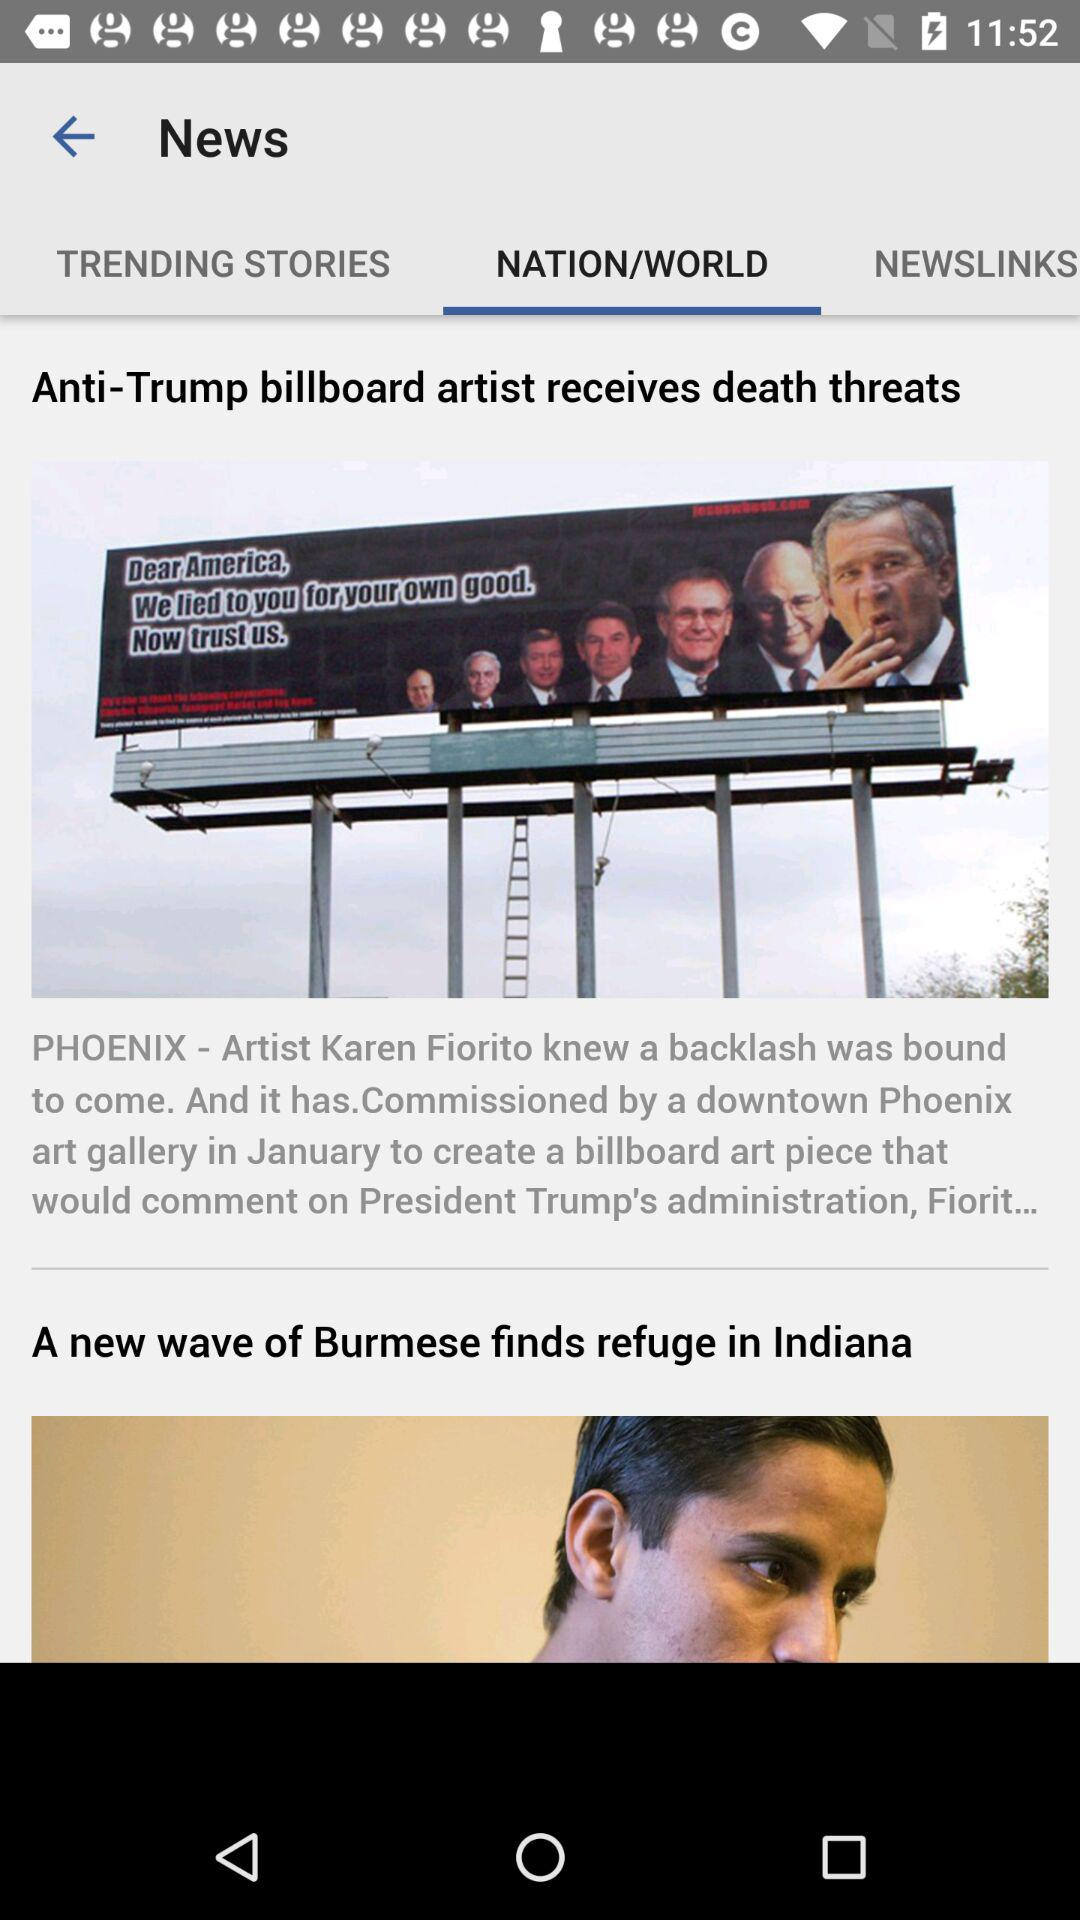Which option is selected? The selected option is "NATION/WORLD". 